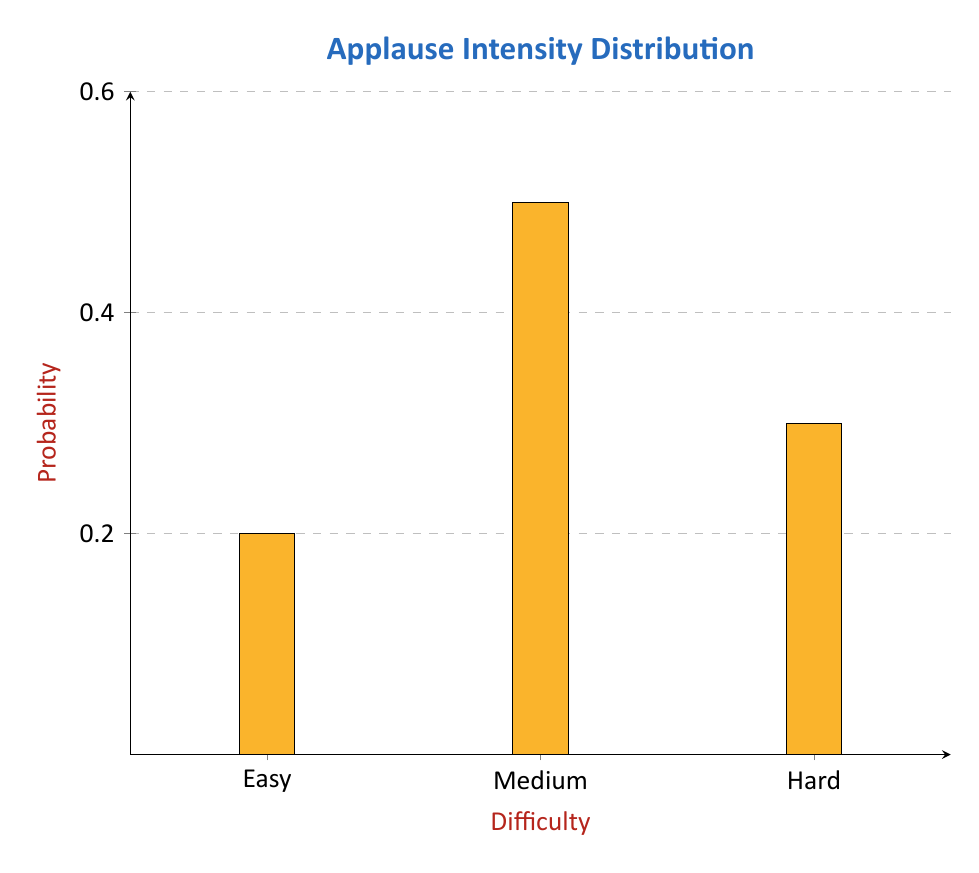Can you answer this question? To solve this problem, we need to use the law of total probability. Let's break it down step-by-step:

1) Let A be the event of high-intensity applause. We need to find P(A).

2) Let E, M, and H represent Easy, Medium, and Hard tricks respectively.

3) The law of total probability states:
   $$P(A) = P(A|E)P(E) + P(A|M)P(M) + P(A|H)P(H)$$

4) We're given:
   $P(A|E) = 0.10$
   $P(A|M) = 0.40$
   $P(A|H) = 0.70$

5) From the graph, we can see:
   $P(E) = 0.20$
   $P(M) = 0.50$
   $P(H) = 0.30$

6) Now, let's substitute these values into our equation:
   $$P(A) = (0.10)(0.20) + (0.40)(0.50) + (0.70)(0.30)$$

7) Calculating:
   $$P(A) = 0.02 + 0.20 + 0.21 = 0.43$$

Therefore, the probability of high-intensity applause for a randomly selected trick is 0.43 or 43%.
Answer: 0.43 